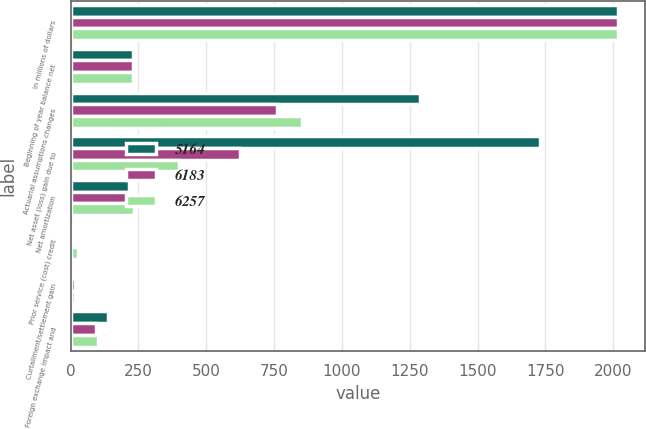Convert chart to OTSL. <chart><loc_0><loc_0><loc_500><loc_500><stacked_bar_chart><ecel><fcel>In millions of dollars<fcel>Beginning of year balance net<fcel>Actuarial assumptions changes<fcel>Net asset (loss) gain due to<fcel>Net amortization<fcel>Prior service (cost) credit<fcel>Curtailment/settlement gain<fcel>Foreign exchange impact and<nl><fcel>5164<fcel>2018<fcel>229<fcel>1288<fcel>1732<fcel>214<fcel>7<fcel>7<fcel>136<nl><fcel>6183<fcel>2017<fcel>229<fcel>760<fcel>625<fcel>229<fcel>4<fcel>17<fcel>93<nl><fcel>6257<fcel>2016<fcel>229<fcel>854<fcel>400<fcel>232<fcel>28<fcel>17<fcel>99<nl></chart> 